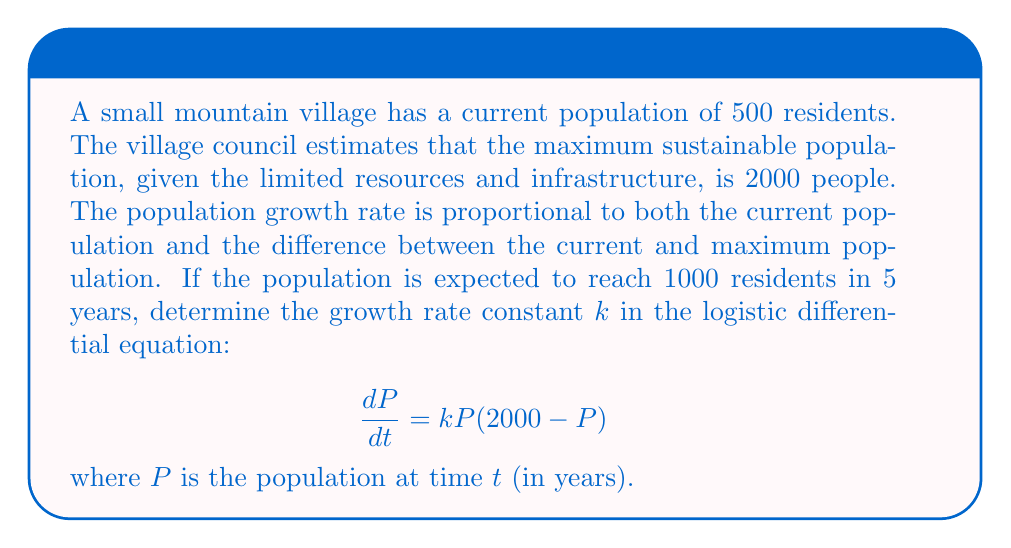Can you answer this question? 1) The logistic differential equation is given by:
   $$\frac{dP}{dt} = kP(2000 - P)$$

2) The solution to this equation is:
   $$P(t) = \frac{2000}{1 + Ce^{-2000kt}}$$
   where $C$ is a constant determined by initial conditions.

3) Given the initial population $P(0) = 500$, we can find $C$:
   $$500 = \frac{2000}{1 + C} \implies C = 3$$

4) Now, we know that $P(5) = 1000$. Let's substitute this into our solution:
   $$1000 = \frac{2000}{1 + 3e^{-10000k}}$$

5) Solve for $k$:
   $$1 + 3e^{-10000k} = 2$$
   $$3e^{-10000k} = 1$$
   $$e^{-10000k} = \frac{1}{3}$$
   $$-10000k = \ln(\frac{1}{3})$$
   $$k = -\frac{\ln(\frac{1}{3})}{10000} = \frac{\ln(3)}{10000}$$

6) Therefore, the growth rate constant $k$ is $\frac{\ln(3)}{10000}$ per year.
Answer: $k = \frac{\ln(3)}{10000}$ per year 